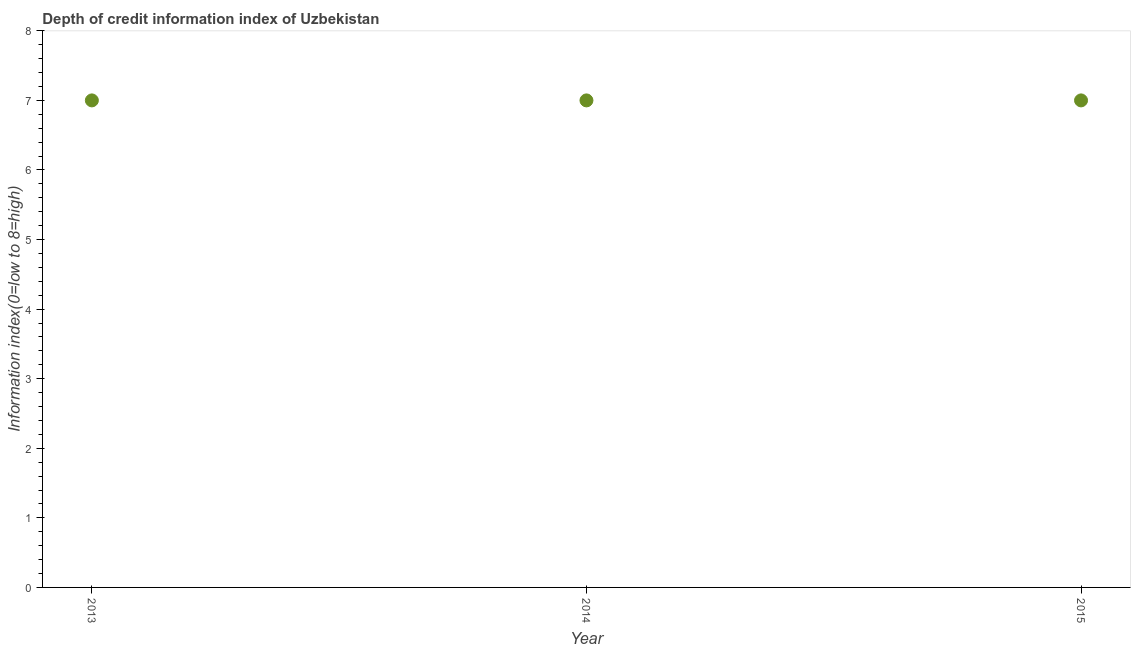What is the depth of credit information index in 2013?
Provide a short and direct response. 7. Across all years, what is the maximum depth of credit information index?
Provide a short and direct response. 7. Across all years, what is the minimum depth of credit information index?
Your answer should be compact. 7. In which year was the depth of credit information index minimum?
Your answer should be very brief. 2013. What is the sum of the depth of credit information index?
Your answer should be compact. 21. What is the difference between the depth of credit information index in 2014 and 2015?
Offer a terse response. 0. What is the median depth of credit information index?
Keep it short and to the point. 7. In how many years, is the depth of credit information index greater than 7.6 ?
Offer a very short reply. 0. What is the ratio of the depth of credit information index in 2013 to that in 2015?
Your answer should be compact. 1. Is the depth of credit information index in 2013 less than that in 2015?
Give a very brief answer. No. Is the difference between the depth of credit information index in 2014 and 2015 greater than the difference between any two years?
Provide a succinct answer. Yes. What is the difference between the highest and the second highest depth of credit information index?
Your response must be concise. 0. Is the sum of the depth of credit information index in 2013 and 2015 greater than the maximum depth of credit information index across all years?
Ensure brevity in your answer.  Yes. What is the difference between the highest and the lowest depth of credit information index?
Keep it short and to the point. 0. How many dotlines are there?
Ensure brevity in your answer.  1. How many years are there in the graph?
Provide a short and direct response. 3. What is the difference between two consecutive major ticks on the Y-axis?
Your answer should be very brief. 1. Does the graph contain any zero values?
Offer a terse response. No. Does the graph contain grids?
Keep it short and to the point. No. What is the title of the graph?
Offer a very short reply. Depth of credit information index of Uzbekistan. What is the label or title of the Y-axis?
Ensure brevity in your answer.  Information index(0=low to 8=high). What is the Information index(0=low to 8=high) in 2014?
Offer a very short reply. 7. What is the difference between the Information index(0=low to 8=high) in 2013 and 2015?
Make the answer very short. 0. What is the ratio of the Information index(0=low to 8=high) in 2013 to that in 2015?
Your response must be concise. 1. What is the ratio of the Information index(0=low to 8=high) in 2014 to that in 2015?
Provide a succinct answer. 1. 